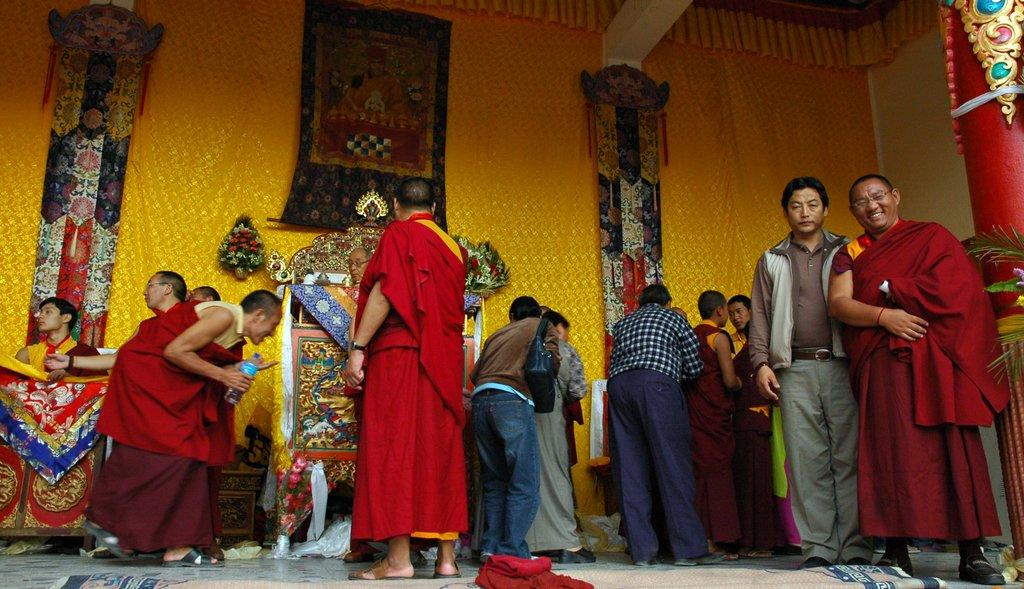How many people are in the group visible in the image? There is a group of people in the image, but the exact number cannot be determined from the provided facts. What is the floor made of in the image? The floor in the image has a carpet on it. What can be seen in the background of the image? In the background of the image, there is a curtain, flower bouquets, and banners. What color is the zebra's lip in the image? There is no zebra or lip present in the image. What angle is the group of people standing at in the image? The angle at which the group of people is standing cannot be determined from the provided facts. 